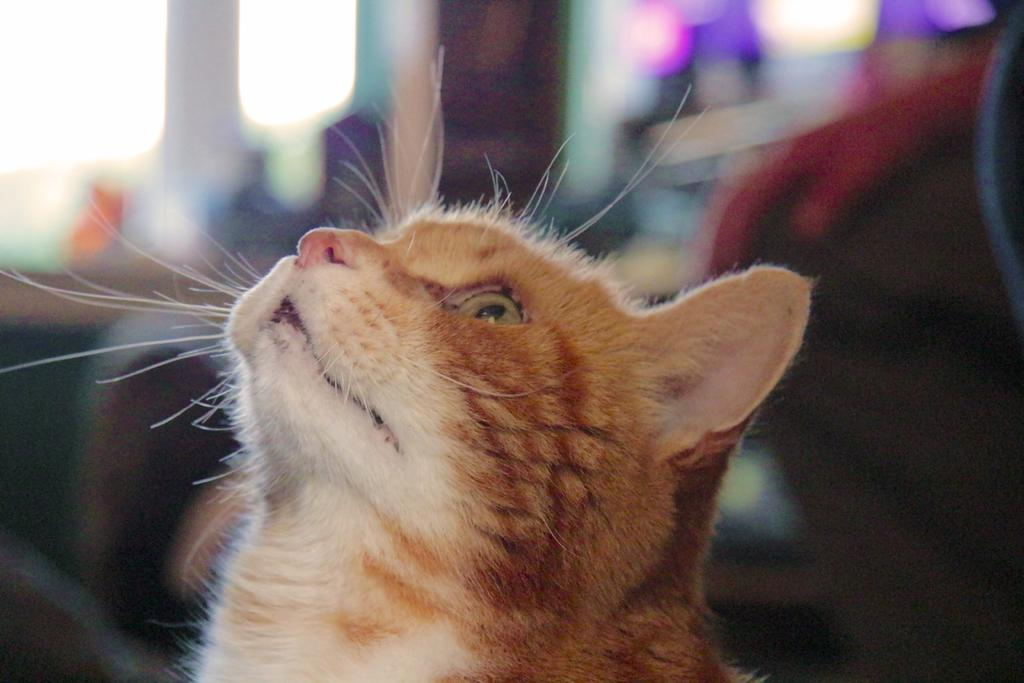What type of animal is present in the image? There is a cat in the image. Can you describe the cat's appearance or behavior in the image? The provided facts do not mention any specific details about the cat's appearance or behavior. Is the cat accompanied by any other objects or figures in the image? The image only shows a cat; there are no other objects or figures mentioned. What type of plate is the cat using to enjoy the summer breeze in the image? There is no plate or mention of summer in the image; it only features a cat. 